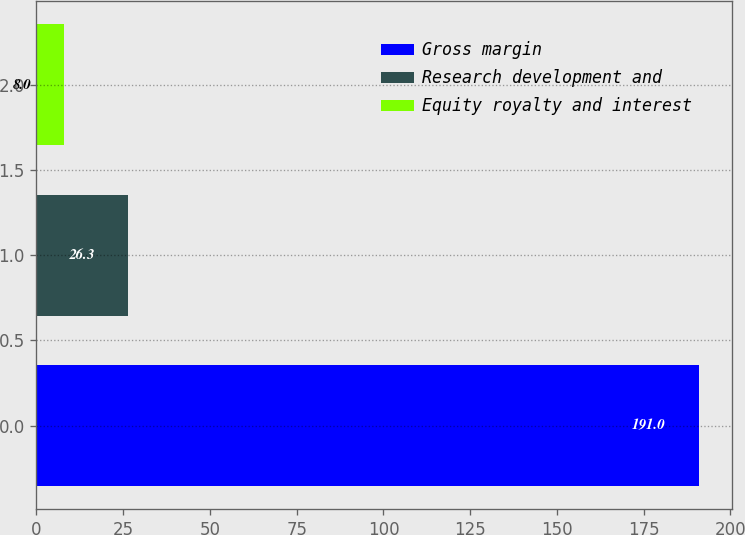Convert chart. <chart><loc_0><loc_0><loc_500><loc_500><bar_chart><fcel>Gross margin<fcel>Research development and<fcel>Equity royalty and interest<nl><fcel>191<fcel>26.3<fcel>8<nl></chart> 